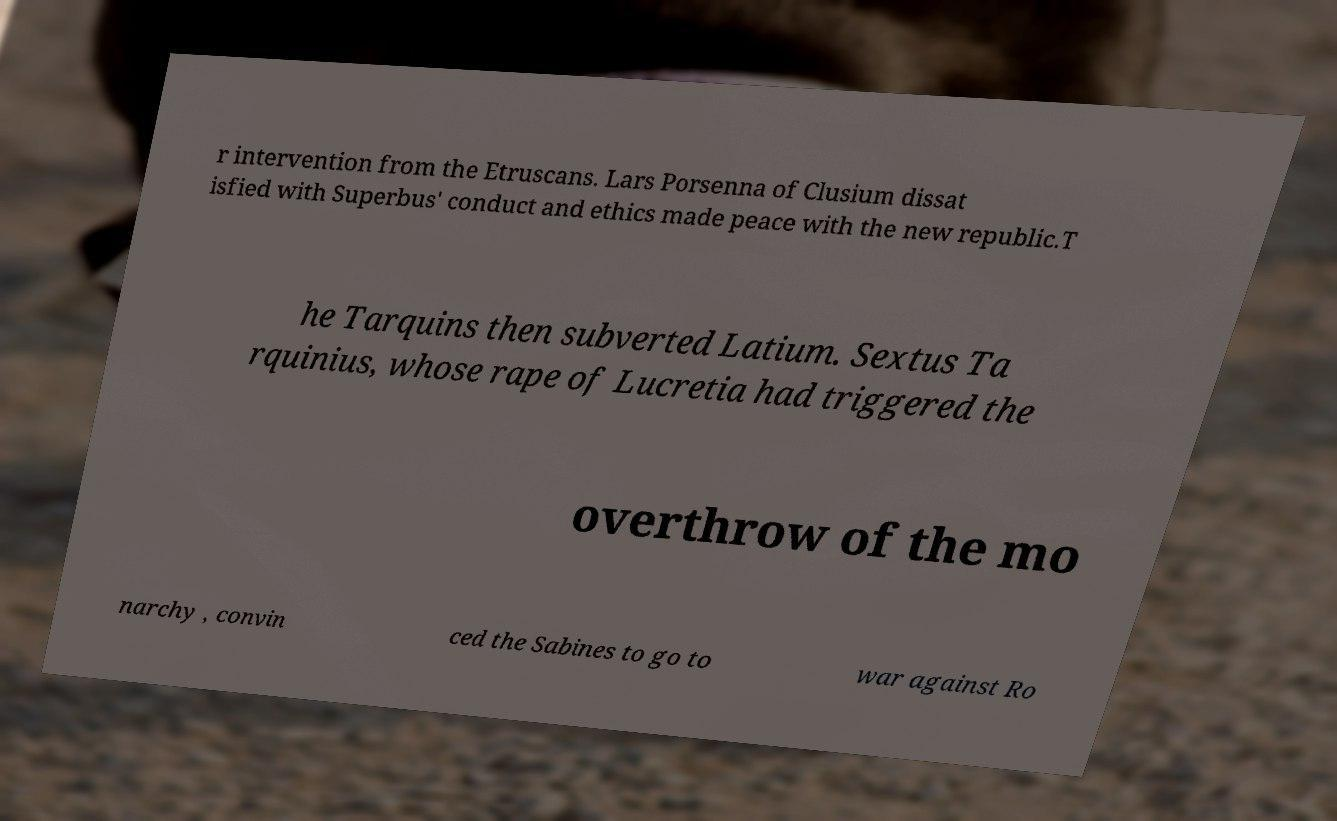Please read and relay the text visible in this image. What does it say? r intervention from the Etruscans. Lars Porsenna of Clusium dissat isfied with Superbus' conduct and ethics made peace with the new republic.T he Tarquins then subverted Latium. Sextus Ta rquinius, whose rape of Lucretia had triggered the overthrow of the mo narchy , convin ced the Sabines to go to war against Ro 